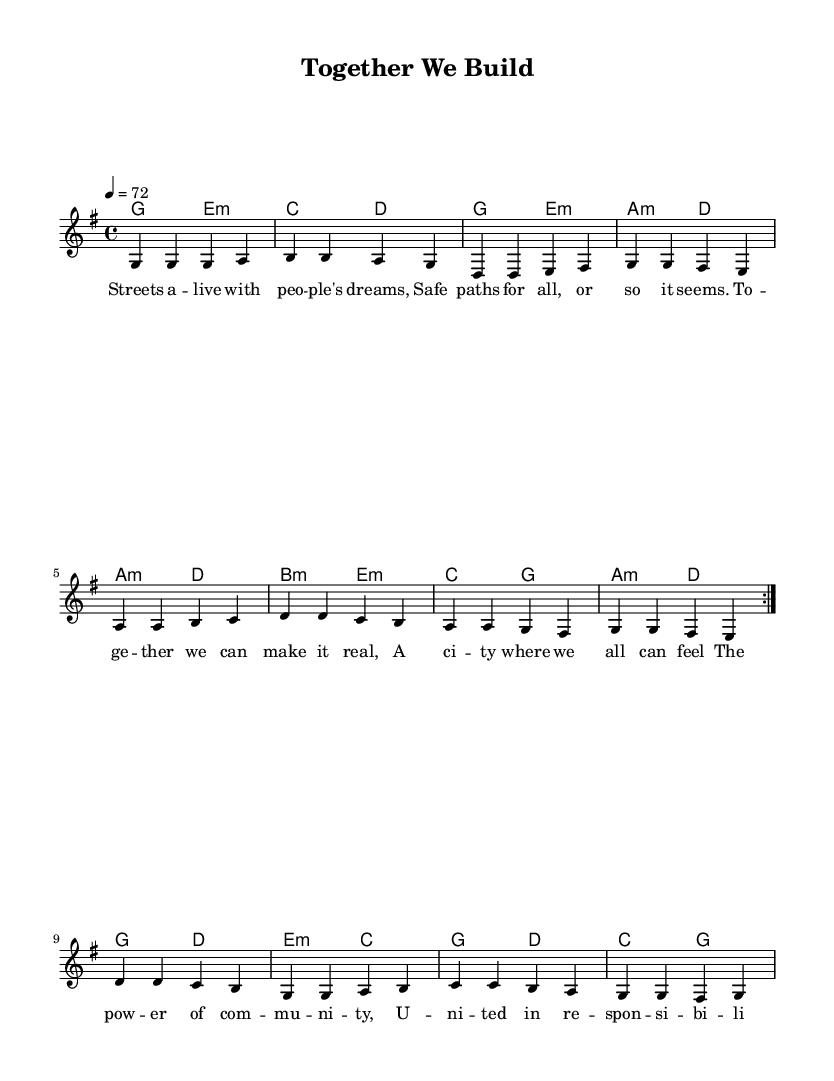What is the key signature of this music? The key signature is G major, which has one sharp (F#).
Answer: G major What is the time signature of this music? The time signature is 4/4, indicating four beats per measure.
Answer: 4/4 What is the tempo marking in this piece? The tempo marking indicates a speed of 72 beats per minute.
Answer: 72 How many measures are repeated in the melody section? The melody section has two measures that are repeated twice according to the volta markings.
Answer: Two measures What is the lyric theme of the song? The theme of the song is about community engagement and creating safe spaces for all.
Answer: Community engagement Which chord appears most frequently in the harmonies? The chord G major appears most frequently in the harmonies.
Answer: G major What is the overall structure of the song based on the lyrics? The song follows a structure that consists of verses, a pre-chorus, and a chorus, creating a cohesive narrative.
Answer: Verse, pre-chorus, chorus 